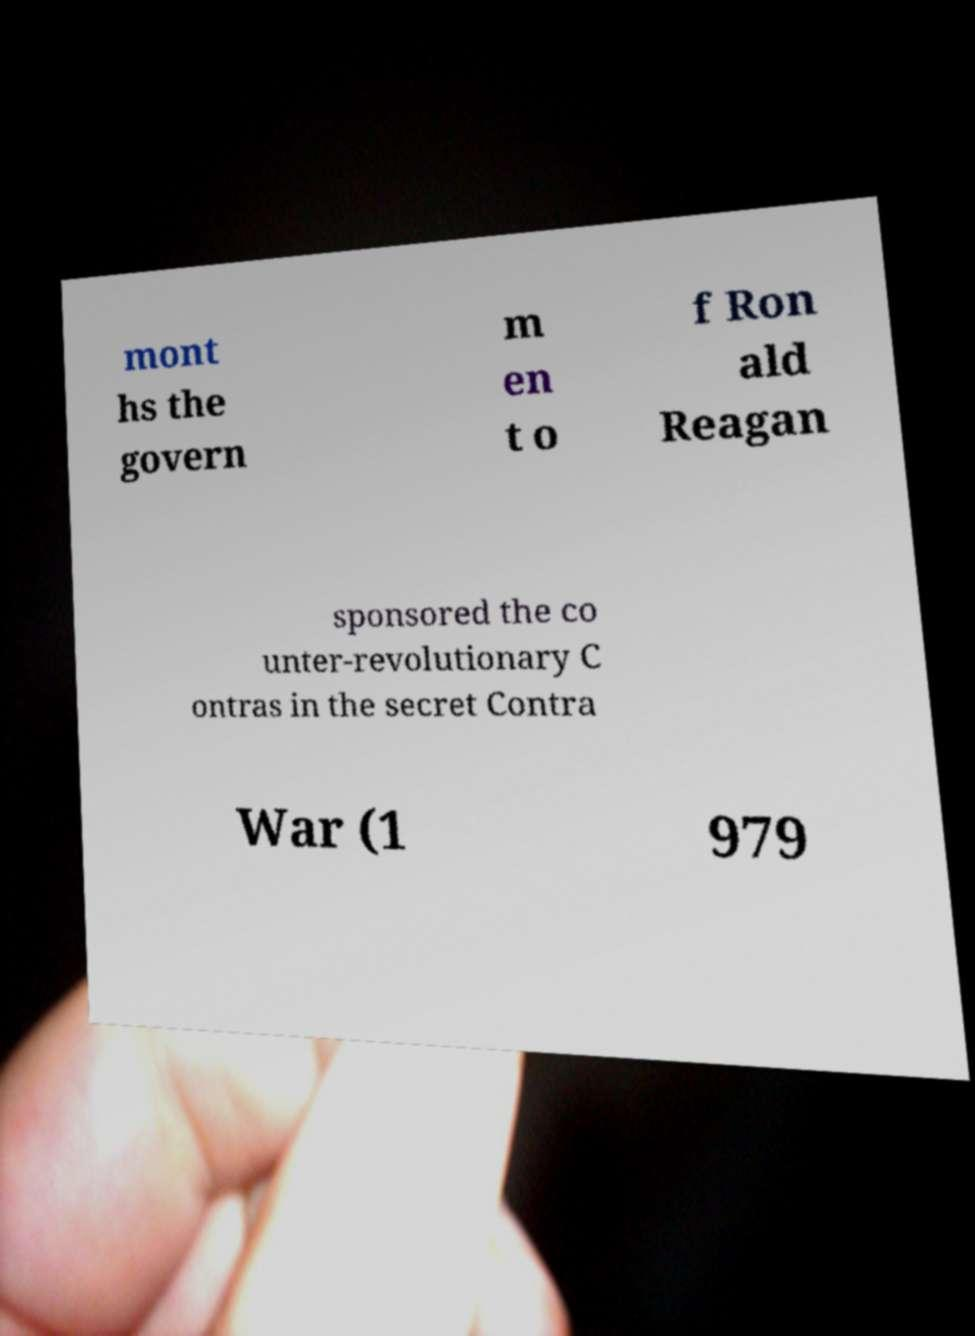Could you assist in decoding the text presented in this image and type it out clearly? mont hs the govern m en t o f Ron ald Reagan sponsored the co unter-revolutionary C ontras in the secret Contra War (1 979 